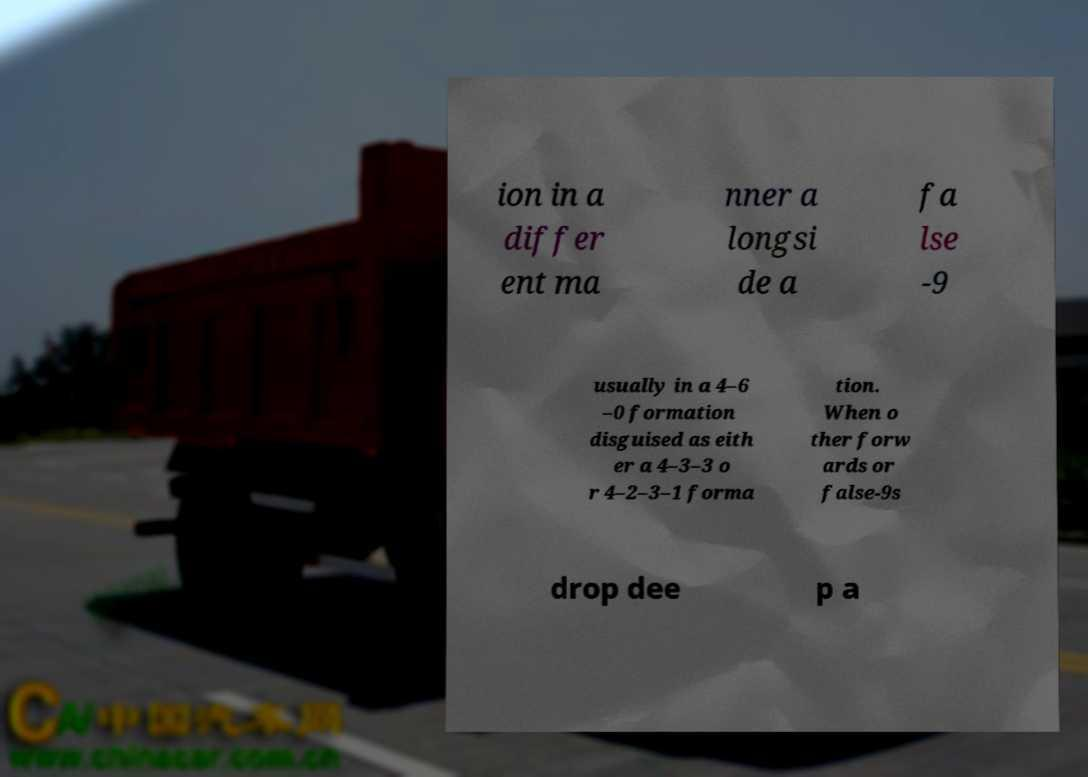Could you assist in decoding the text presented in this image and type it out clearly? ion in a differ ent ma nner a longsi de a fa lse -9 usually in a 4–6 –0 formation disguised as eith er a 4–3–3 o r 4–2–3–1 forma tion. When o ther forw ards or false-9s drop dee p a 